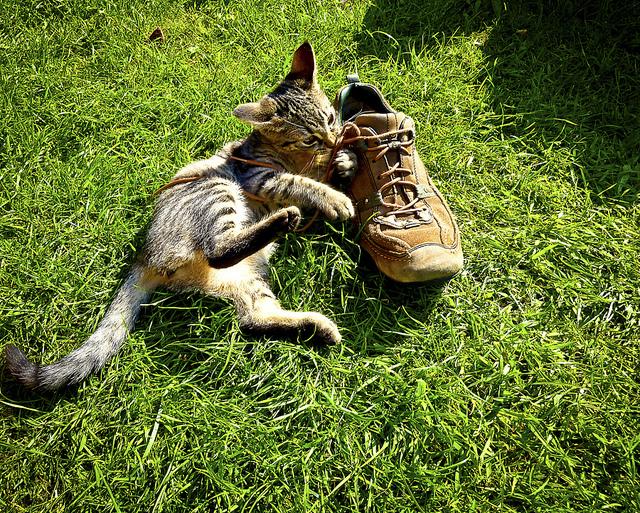IS that a dress shoe?
Keep it brief. No. Is the cat trying to eat the shoe?
Keep it brief. No. Is that the left or right shoe?
Quick response, please. Left. 